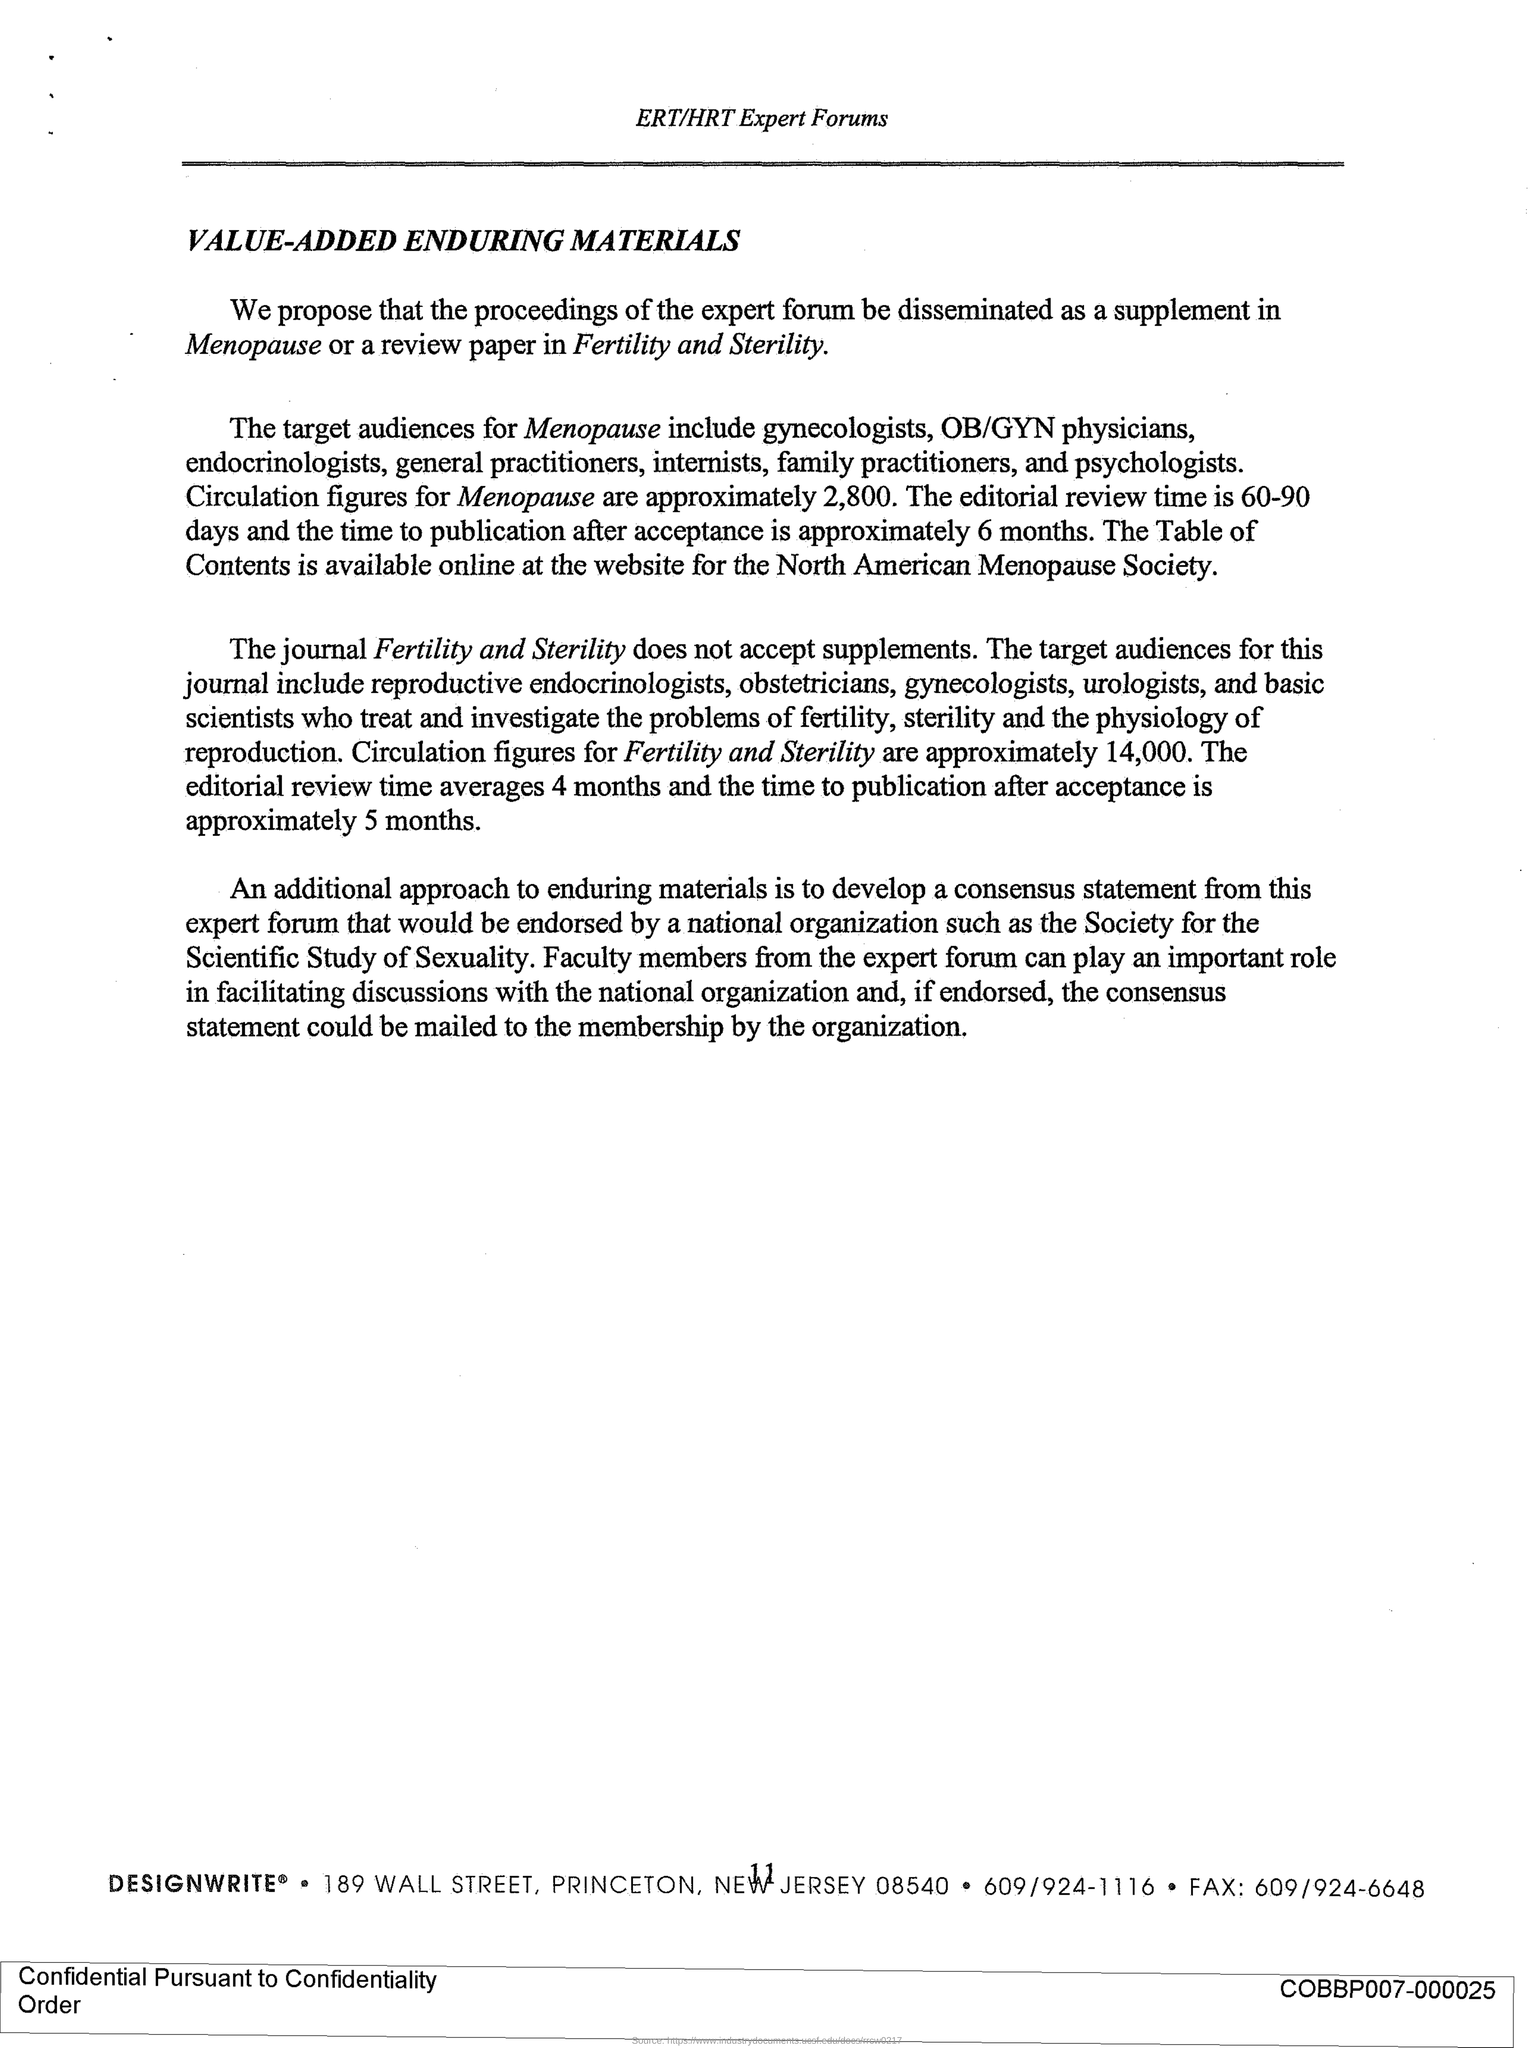Give some essential details in this illustration. The title of this document is 'Value-Added Enduring Materials.' The circulation figures for the journal Fertility and Sterility are approximately 14,000. The header of the document mentions the ERT/HRT Expert Forums forum. Fertility and Sterility is a journal that does not accept supplements. 